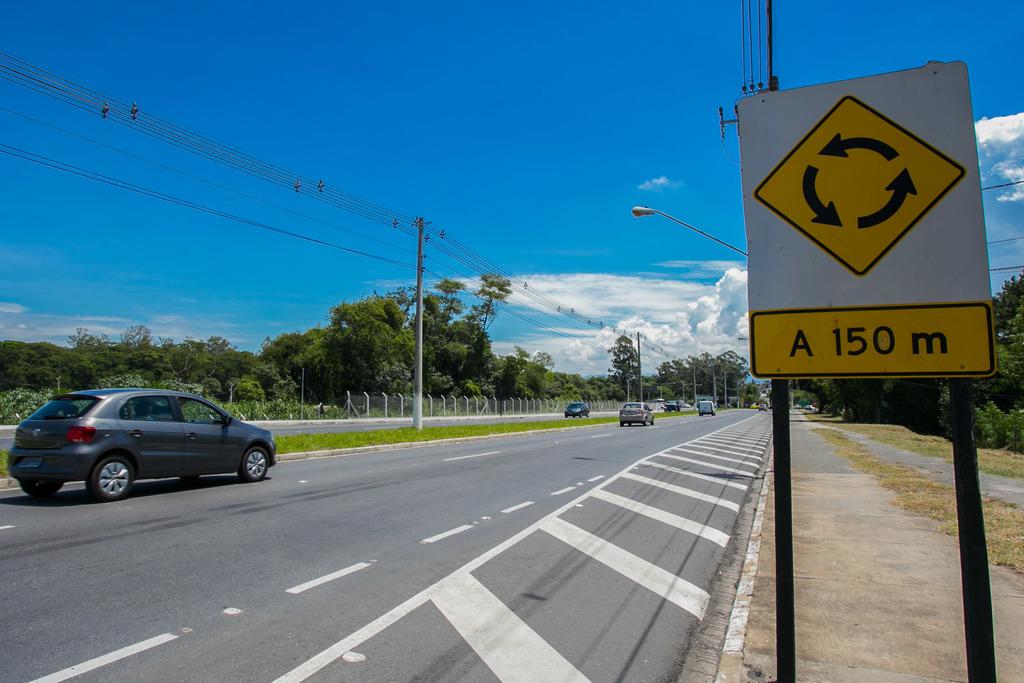What is the speed limit on this street?
Ensure brevity in your answer.  150 m. How many meters is the round about?
Keep it short and to the point. 150. 